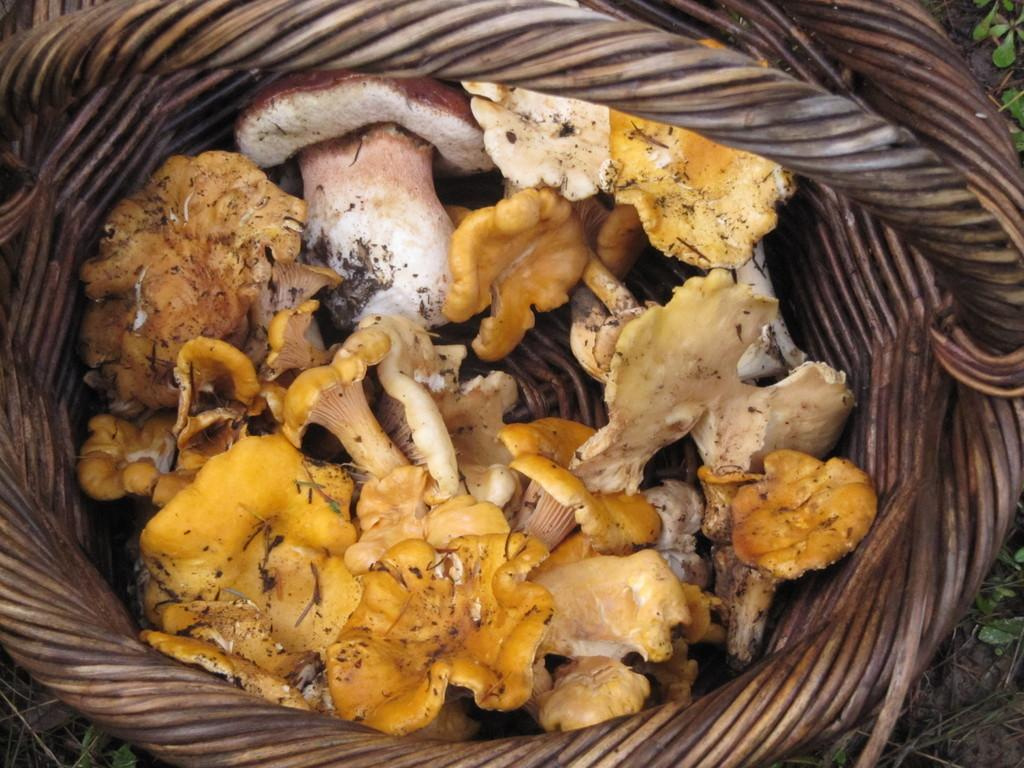What type of fungi can be seen in the image? There are mushrooms in the image. How are the mushrooms arranged or contained in the image? The mushrooms are placed in a basket. What type of truck is visible in the image? There is no truck present in the image; it features mushrooms placed in a basket. 